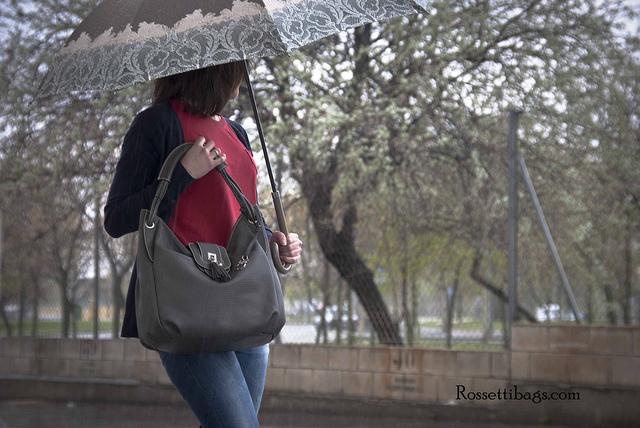Is it raining?
Concise answer only. Yes. What is this person holding?
Give a very brief answer. Umbrella. What company website is present on this photo?
Short answer required. Rossetti bagscom. 